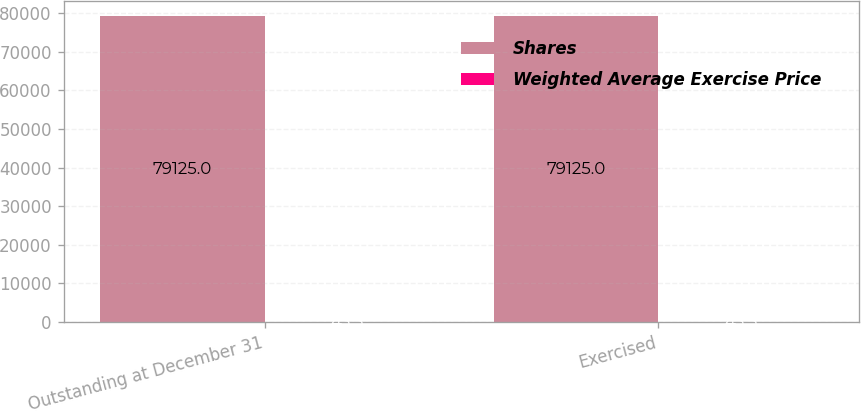<chart> <loc_0><loc_0><loc_500><loc_500><stacked_bar_chart><ecel><fcel>Outstanding at December 31<fcel>Exercised<nl><fcel>Shares<fcel>79125<fcel>79125<nl><fcel>Weighted Average Exercise Price<fcel>43.5<fcel>43.5<nl></chart> 